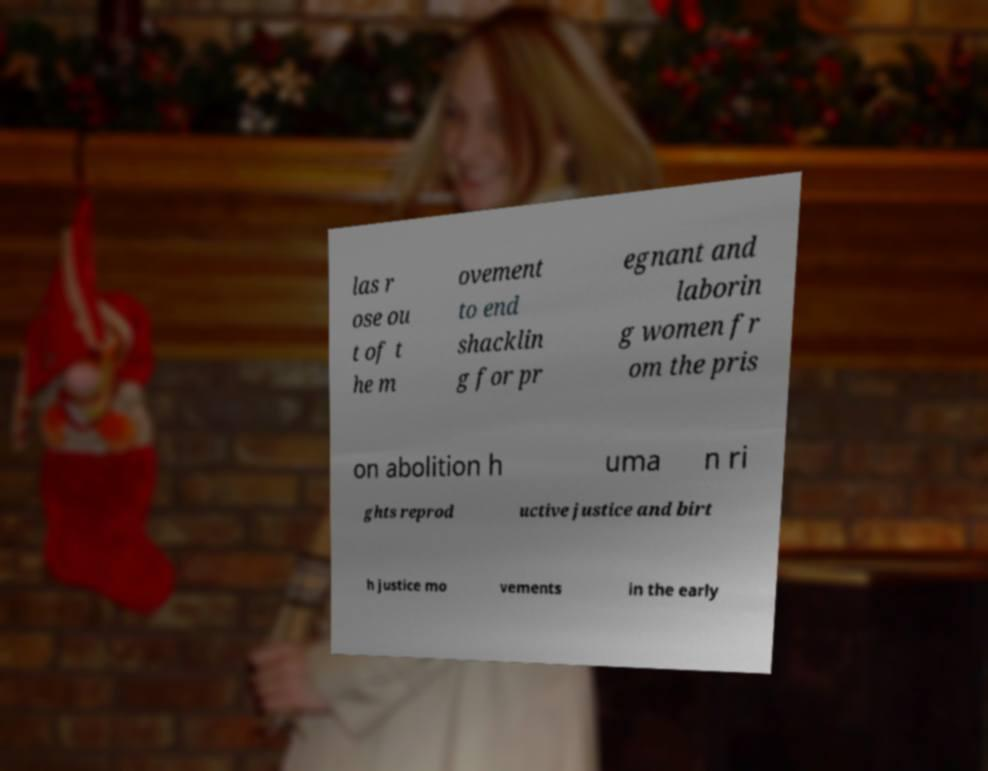For documentation purposes, I need the text within this image transcribed. Could you provide that? las r ose ou t of t he m ovement to end shacklin g for pr egnant and laborin g women fr om the pris on abolition h uma n ri ghts reprod uctive justice and birt h justice mo vements in the early 